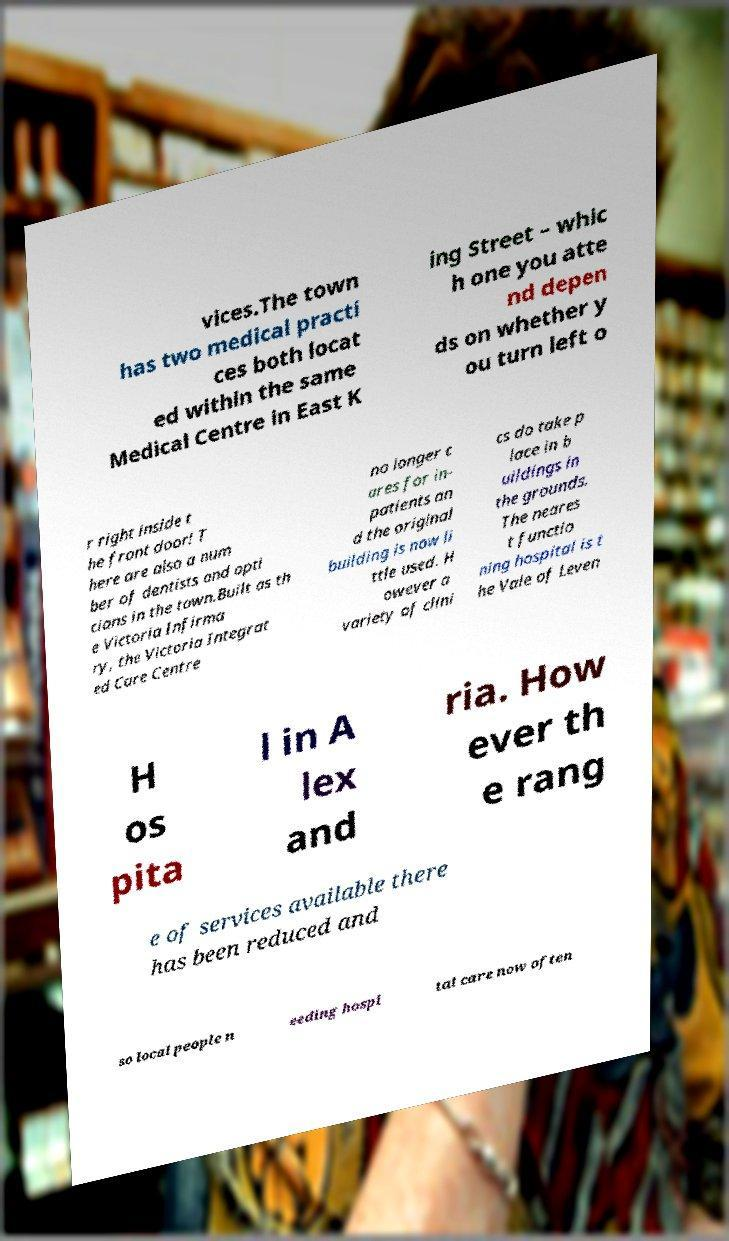For documentation purposes, I need the text within this image transcribed. Could you provide that? vices.The town has two medical practi ces both locat ed within the same Medical Centre in East K ing Street – whic h one you atte nd depen ds on whether y ou turn left o r right inside t he front door! T here are also a num ber of dentists and opti cians in the town.Built as th e Victoria Infirma ry, the Victoria Integrat ed Care Centre no longer c ares for in- patients an d the original building is now li ttle used. H owever a variety of clini cs do take p lace in b uildings in the grounds. The neares t functio ning hospital is t he Vale of Leven H os pita l in A lex and ria. How ever th e rang e of services available there has been reduced and so local people n eeding hospi tal care now often 